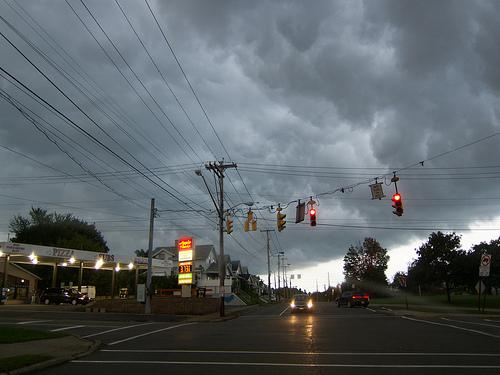Question: what do red traffic lights mean?
Choices:
A. Do not cross.
B. Danger.
C. It's not your turn to cross.
D. Stop.
Answer with the letter. Answer: D Question: what color are the traffic lights?
Choices:
A. Red.
B. Green.
C. Yellow.
D. White.
Answer with the letter. Answer: A Question: what type of Italian food does the gas station advertise?
Choices:
A. Pizza.
B. Spaghetti.
C. Cassarole.
D. Lasagana.
Answer with the letter. Answer: A Question: how many street lights are hanging?
Choices:
A. Two.
B. Three.
C. Four.
D. Five.
Answer with the letter. Answer: D Question: how many cars are on the street?
Choices:
A. Four.
B. Five.
C. Two.
D. Six.
Answer with the letter. Answer: C Question: what color are the clouds?
Choices:
A. White.
B. Gray.
C. Dark gray.
D. Light gray.
Answer with the letter. Answer: B 